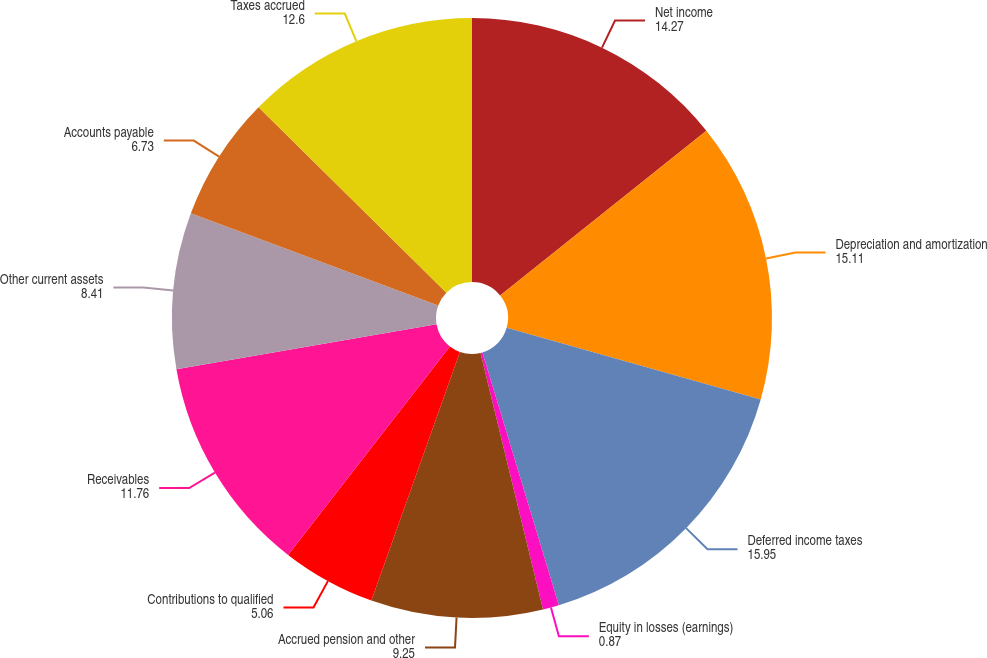Convert chart to OTSL. <chart><loc_0><loc_0><loc_500><loc_500><pie_chart><fcel>Net income<fcel>Depreciation and amortization<fcel>Deferred income taxes<fcel>Equity in losses (earnings)<fcel>Accrued pension and other<fcel>Contributions to qualified<fcel>Receivables<fcel>Other current assets<fcel>Accounts payable<fcel>Taxes accrued<nl><fcel>14.27%<fcel>15.11%<fcel>15.95%<fcel>0.87%<fcel>9.25%<fcel>5.06%<fcel>11.76%<fcel>8.41%<fcel>6.73%<fcel>12.6%<nl></chart> 